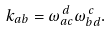<formula> <loc_0><loc_0><loc_500><loc_500>k _ { a b } = \omega _ { a c } ^ { \, d } \omega _ { b d } ^ { \, c } .</formula> 